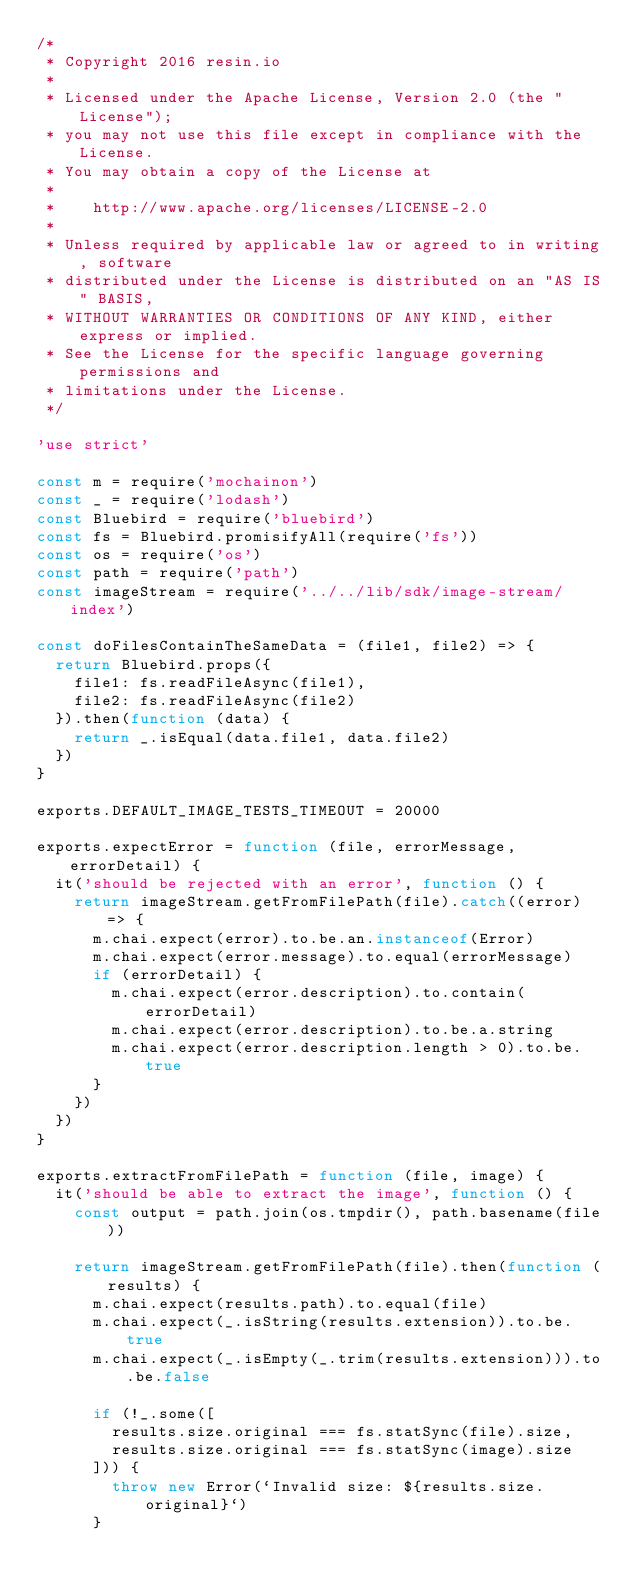<code> <loc_0><loc_0><loc_500><loc_500><_JavaScript_>/*
 * Copyright 2016 resin.io
 *
 * Licensed under the Apache License, Version 2.0 (the "License");
 * you may not use this file except in compliance with the License.
 * You may obtain a copy of the License at
 *
 *    http://www.apache.org/licenses/LICENSE-2.0
 *
 * Unless required by applicable law or agreed to in writing, software
 * distributed under the License is distributed on an "AS IS" BASIS,
 * WITHOUT WARRANTIES OR CONDITIONS OF ANY KIND, either express or implied.
 * See the License for the specific language governing permissions and
 * limitations under the License.
 */

'use strict'

const m = require('mochainon')
const _ = require('lodash')
const Bluebird = require('bluebird')
const fs = Bluebird.promisifyAll(require('fs'))
const os = require('os')
const path = require('path')
const imageStream = require('../../lib/sdk/image-stream/index')

const doFilesContainTheSameData = (file1, file2) => {
  return Bluebird.props({
    file1: fs.readFileAsync(file1),
    file2: fs.readFileAsync(file2)
  }).then(function (data) {
    return _.isEqual(data.file1, data.file2)
  })
}

exports.DEFAULT_IMAGE_TESTS_TIMEOUT = 20000

exports.expectError = function (file, errorMessage, errorDetail) {
  it('should be rejected with an error', function () {
    return imageStream.getFromFilePath(file).catch((error) => {
      m.chai.expect(error).to.be.an.instanceof(Error)
      m.chai.expect(error.message).to.equal(errorMessage)
      if (errorDetail) {
        m.chai.expect(error.description).to.contain(errorDetail)
        m.chai.expect(error.description).to.be.a.string
        m.chai.expect(error.description.length > 0).to.be.true
      }
    })
  })
}

exports.extractFromFilePath = function (file, image) {
  it('should be able to extract the image', function () {
    const output = path.join(os.tmpdir(), path.basename(file))

    return imageStream.getFromFilePath(file).then(function (results) {
      m.chai.expect(results.path).to.equal(file)
      m.chai.expect(_.isString(results.extension)).to.be.true
      m.chai.expect(_.isEmpty(_.trim(results.extension))).to.be.false

      if (!_.some([
        results.size.original === fs.statSync(file).size,
        results.size.original === fs.statSync(image).size
      ])) {
        throw new Error(`Invalid size: ${results.size.original}`)
      }
</code> 